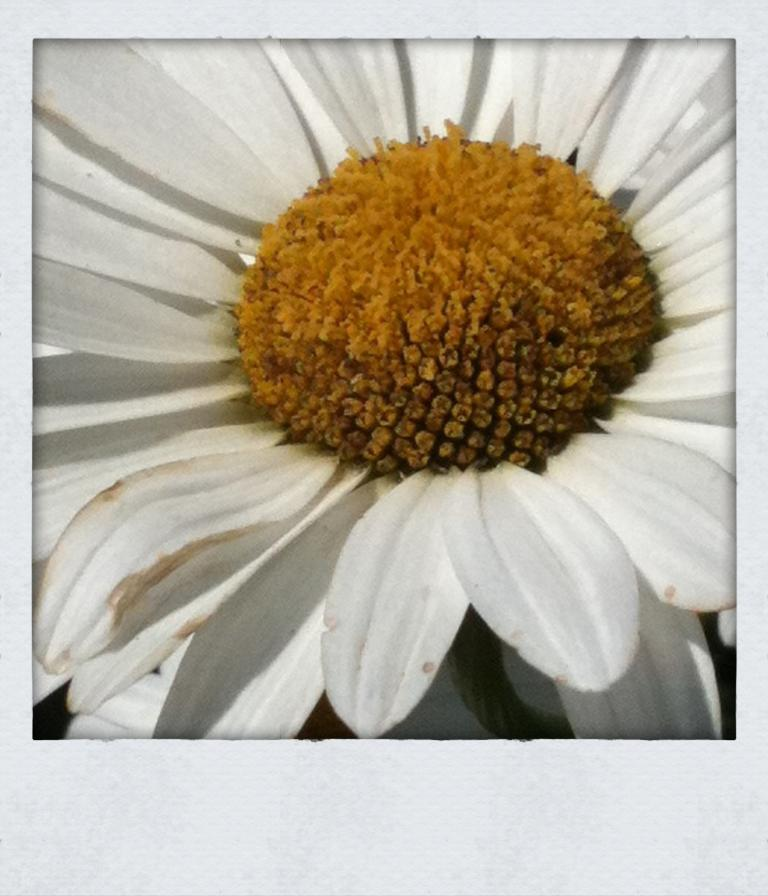What is the main subject of the image? There is a flower in the image. What is the net worth of the flower in the image? The net worth of the flower cannot be determined from the image, as it is not a living being with wealth. 